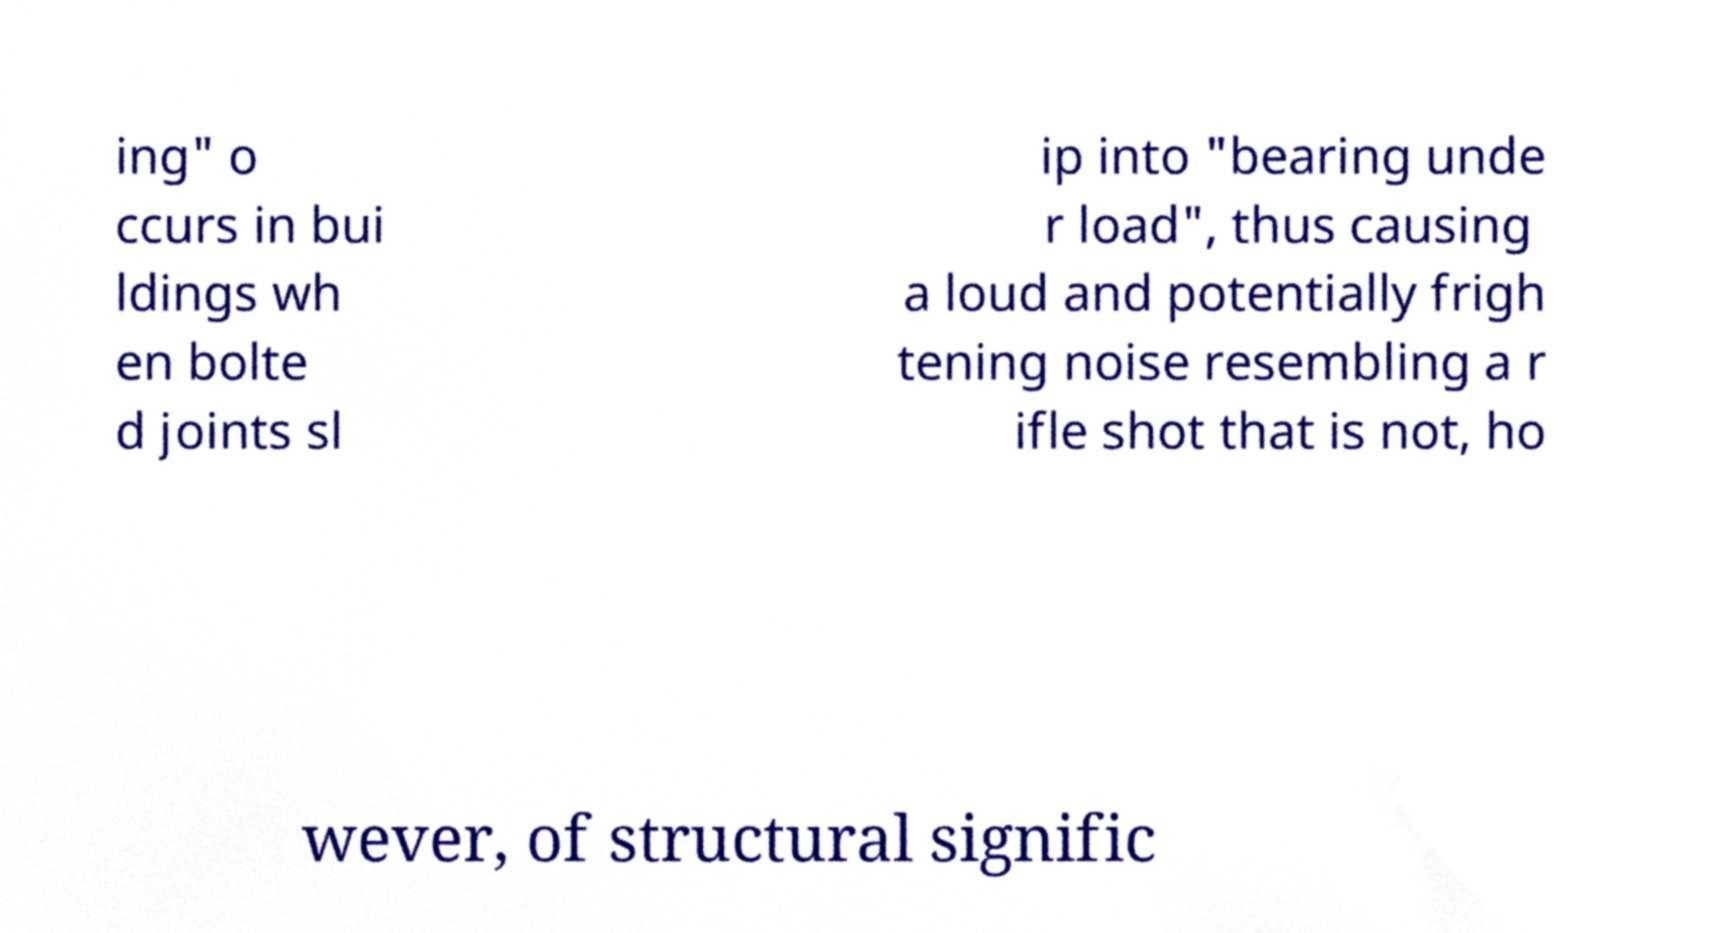Could you assist in decoding the text presented in this image and type it out clearly? ing" o ccurs in bui ldings wh en bolte d joints sl ip into "bearing unde r load", thus causing a loud and potentially frigh tening noise resembling a r ifle shot that is not, ho wever, of structural signific 